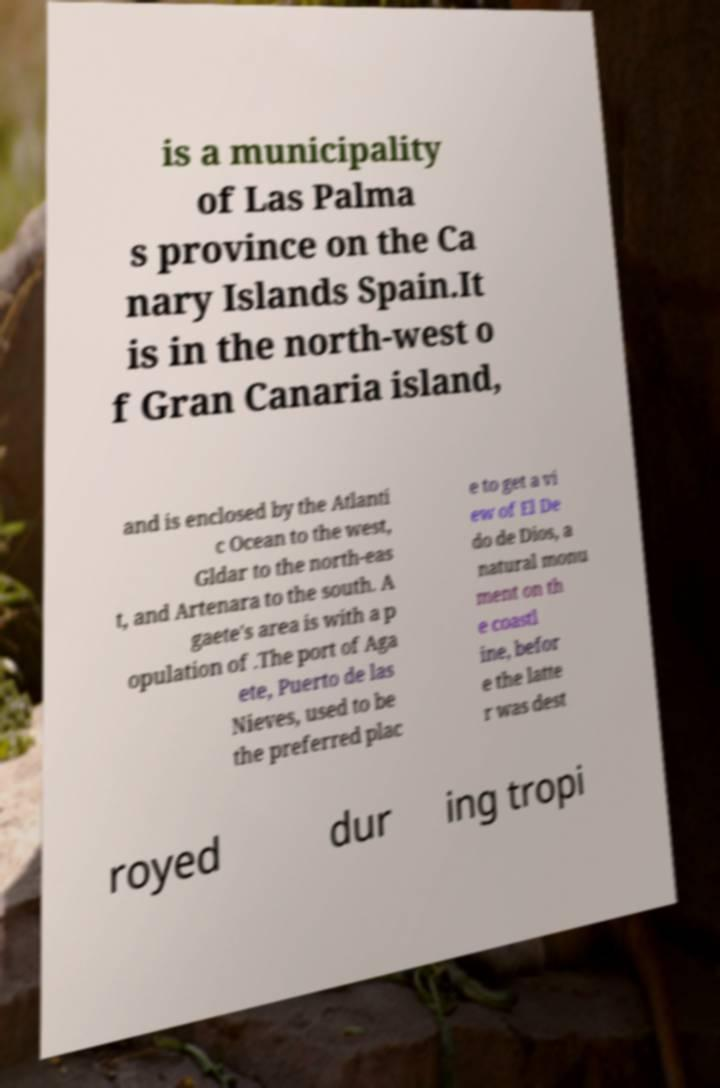For documentation purposes, I need the text within this image transcribed. Could you provide that? is a municipality of Las Palma s province on the Ca nary Islands Spain.It is in the north-west o f Gran Canaria island, and is enclosed by the Atlanti c Ocean to the west, Gldar to the north-eas t, and Artenara to the south. A gaete's area is with a p opulation of .The port of Aga ete, Puerto de las Nieves, used to be the preferred plac e to get a vi ew of El De do de Dios, a natural monu ment on th e coastl ine, befor e the latte r was dest royed dur ing tropi 